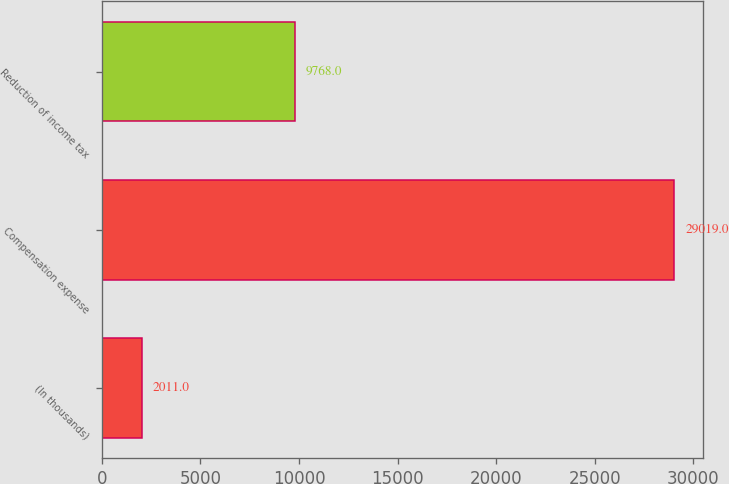Convert chart to OTSL. <chart><loc_0><loc_0><loc_500><loc_500><bar_chart><fcel>(In thousands)<fcel>Compensation expense<fcel>Reduction of income tax<nl><fcel>2011<fcel>29019<fcel>9768<nl></chart> 